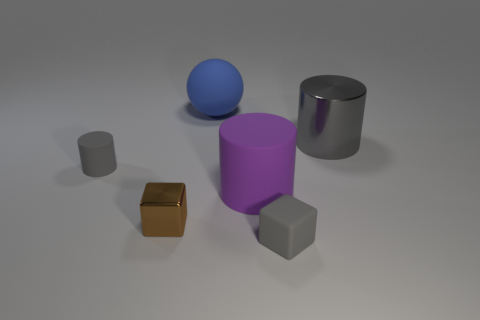Add 3 yellow balls. How many objects exist? 9 Subtract all spheres. How many objects are left? 5 Add 3 tiny blue metallic cylinders. How many tiny blue metallic cylinders exist? 3 Subtract 1 gray cylinders. How many objects are left? 5 Subtract all blue objects. Subtract all blue objects. How many objects are left? 4 Add 6 purple objects. How many purple objects are left? 7 